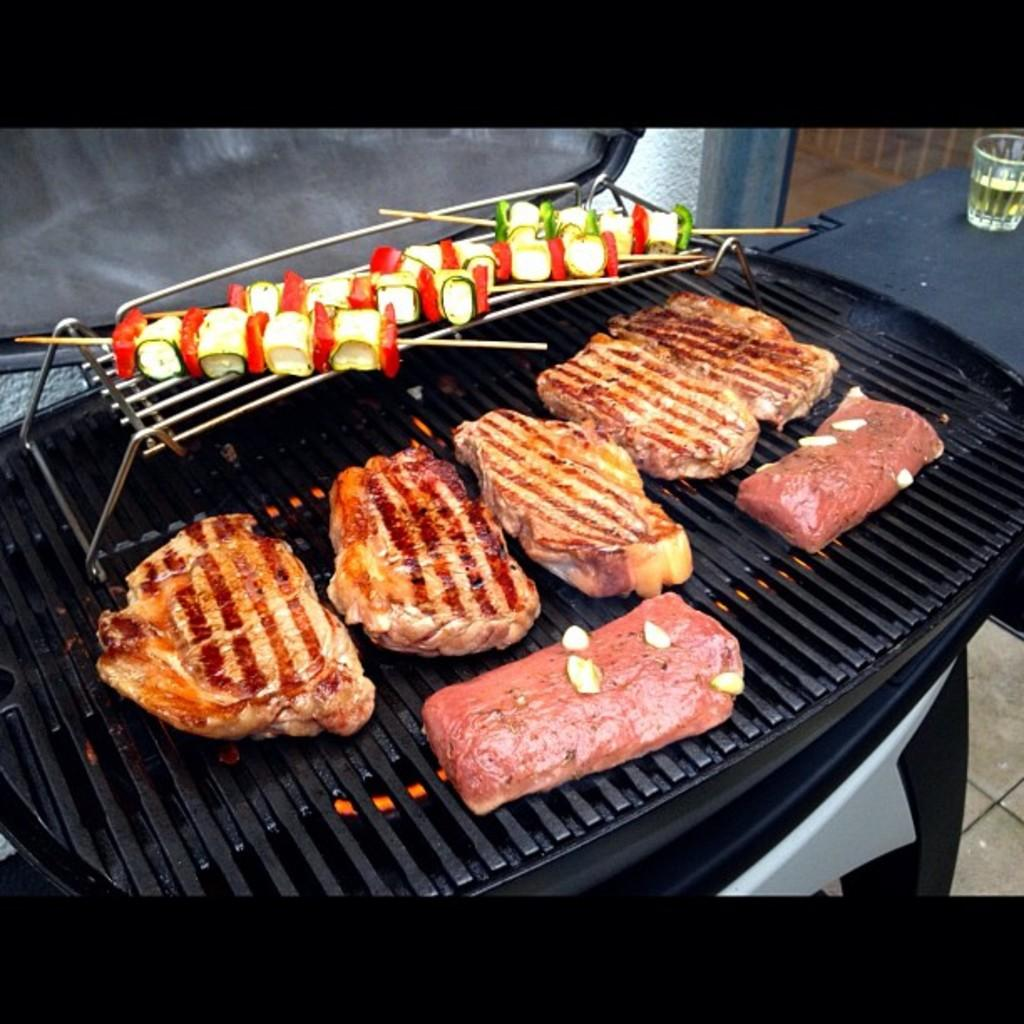What is the color of the grill in the image? The grill in the image is black. What is on the grill in the image? There are pieces of food on the grill. What object can be seen on a desk in the image? There is a glass on a desk in the image. Can you tell me how many people are jumping in the image? There are no people or jumping activities depicted in the image. What verse is being recited by the grill in the image? There is no verse or recitation happening in the image; it features a grill with food on it and a glass on a desk. 